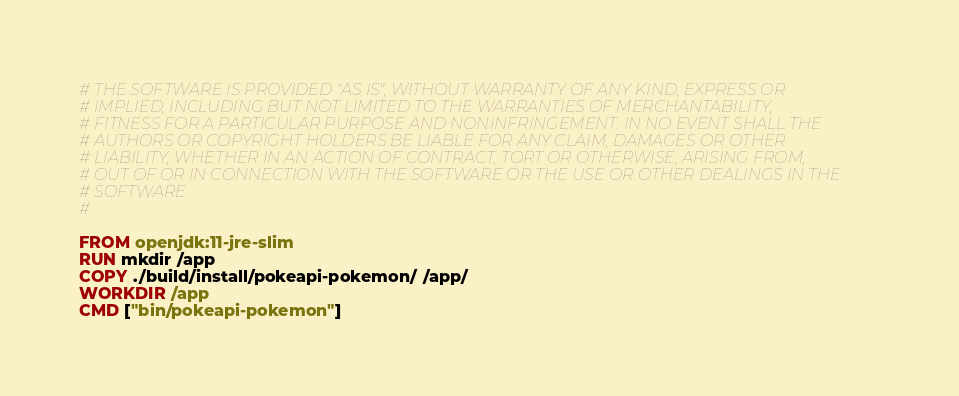<code> <loc_0><loc_0><loc_500><loc_500><_Dockerfile_># THE SOFTWARE IS PROVIDED "AS IS", WITHOUT WARRANTY OF ANY KIND, EXPRESS OR
# IMPLIED, INCLUDING BUT NOT LIMITED TO THE WARRANTIES OF MERCHANTABILITY,
# FITNESS FOR A PARTICULAR PURPOSE AND NONINFRINGEMENT. IN NO EVENT SHALL THE
# AUTHORS OR COPYRIGHT HOLDERS BE LIABLE FOR ANY CLAIM, DAMAGES OR OTHER
# LIABILITY, WHETHER IN AN ACTION OF CONTRACT, TORT OR OTHERWISE, ARISING FROM,
# OUT OF OR IN CONNECTION WITH THE SOFTWARE OR THE USE OR OTHER DEALINGS IN THE
# SOFTWARE.
#

FROM openjdk:11-jre-slim
RUN mkdir /app
COPY ./build/install/pokeapi-pokemon/ /app/
WORKDIR /app
CMD ["bin/pokeapi-pokemon"]
</code> 